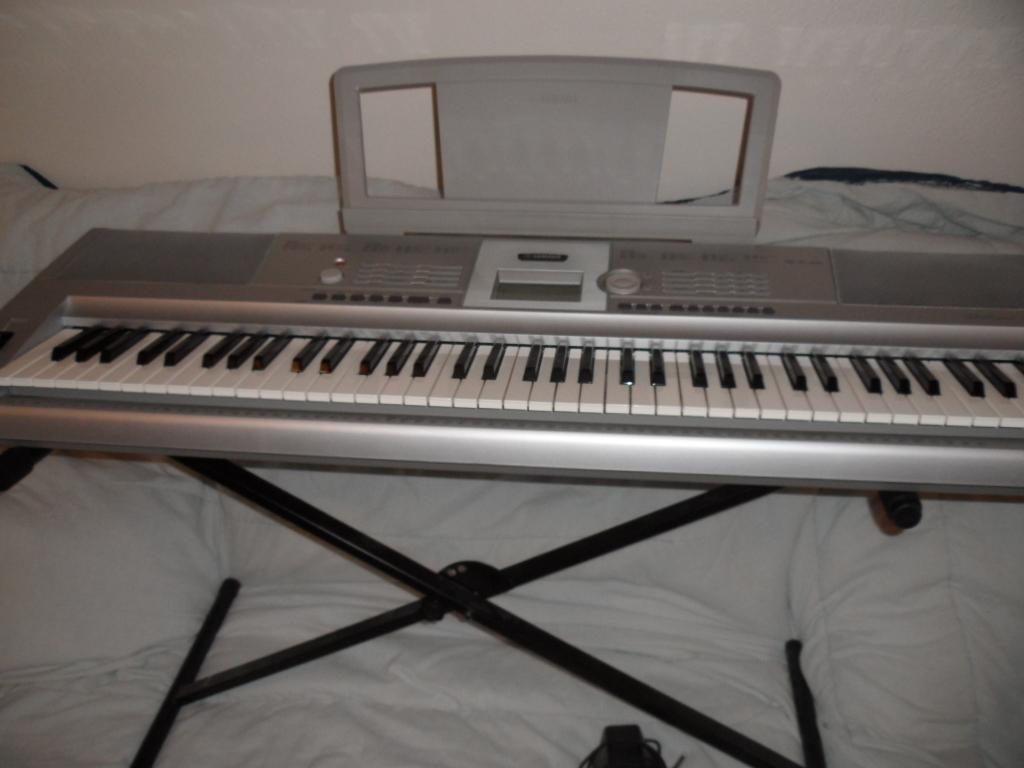What is placed on the bed in the image? There is a keyboard with a stand on the bed. What can be observed about the keys on the keyboard? The keyboard has black and white keys. What is visible in the background of the image? There is a wall visible behind the bed. What type of amusement can be seen in the image? There is no amusement present in the image; it features a keyboard on a bed with a wall in the background. Can you tell me how many blades are visible in the image? There are no blades present in the image. 